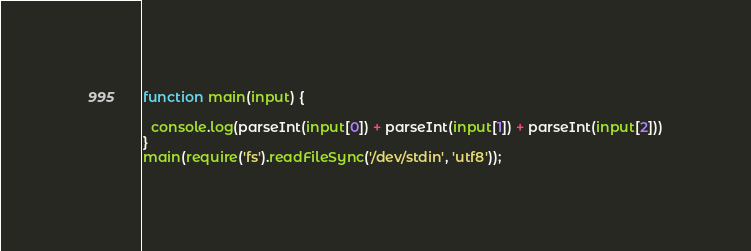Convert code to text. <code><loc_0><loc_0><loc_500><loc_500><_TypeScript_>function main(input) {
  
  console.log(parseInt(input[0]) + parseInt(input[1]) + parseInt(input[2]))
}
main(require('fs').readFileSync('/dev/stdin', 'utf8'));</code> 